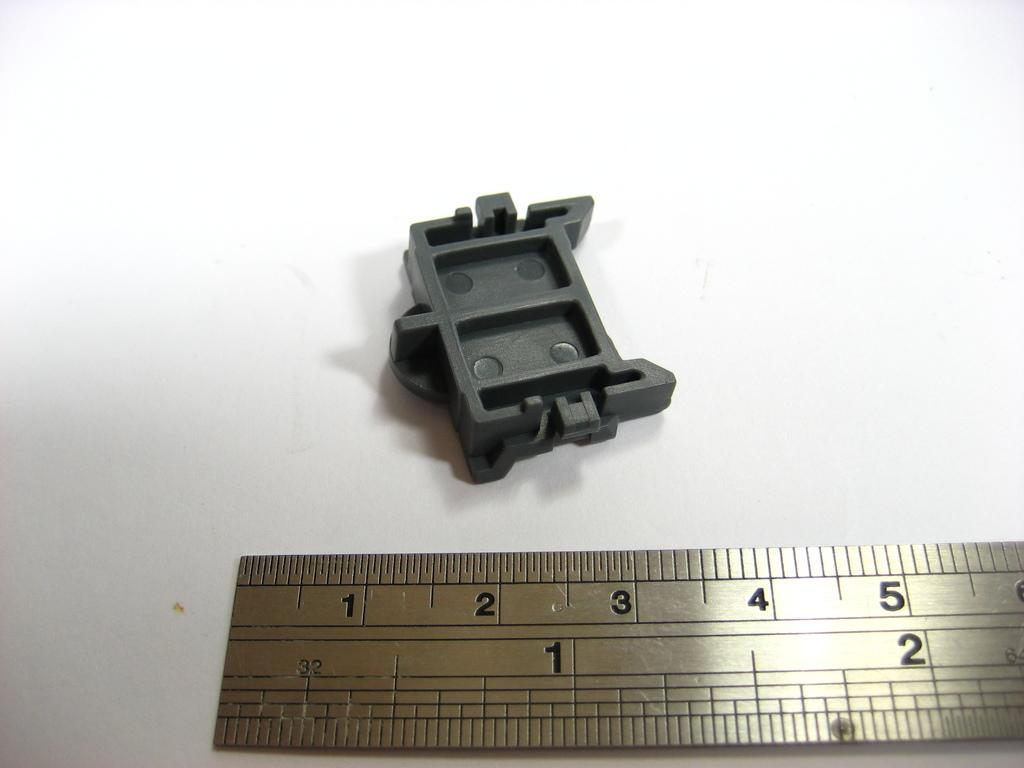<image>
Render a clear and concise summary of the photo. A plastic object is above a ruler that shows two inches. 